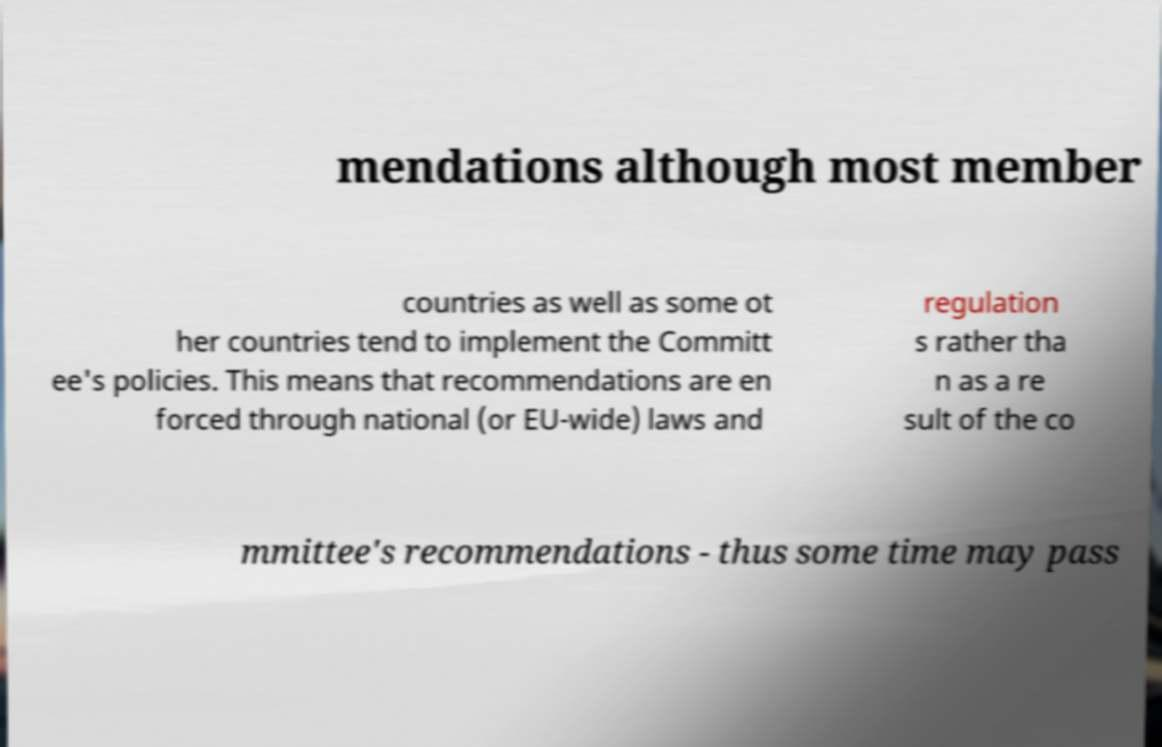For documentation purposes, I need the text within this image transcribed. Could you provide that? mendations although most member countries as well as some ot her countries tend to implement the Committ ee's policies. This means that recommendations are en forced through national (or EU-wide) laws and regulation s rather tha n as a re sult of the co mmittee's recommendations - thus some time may pass 